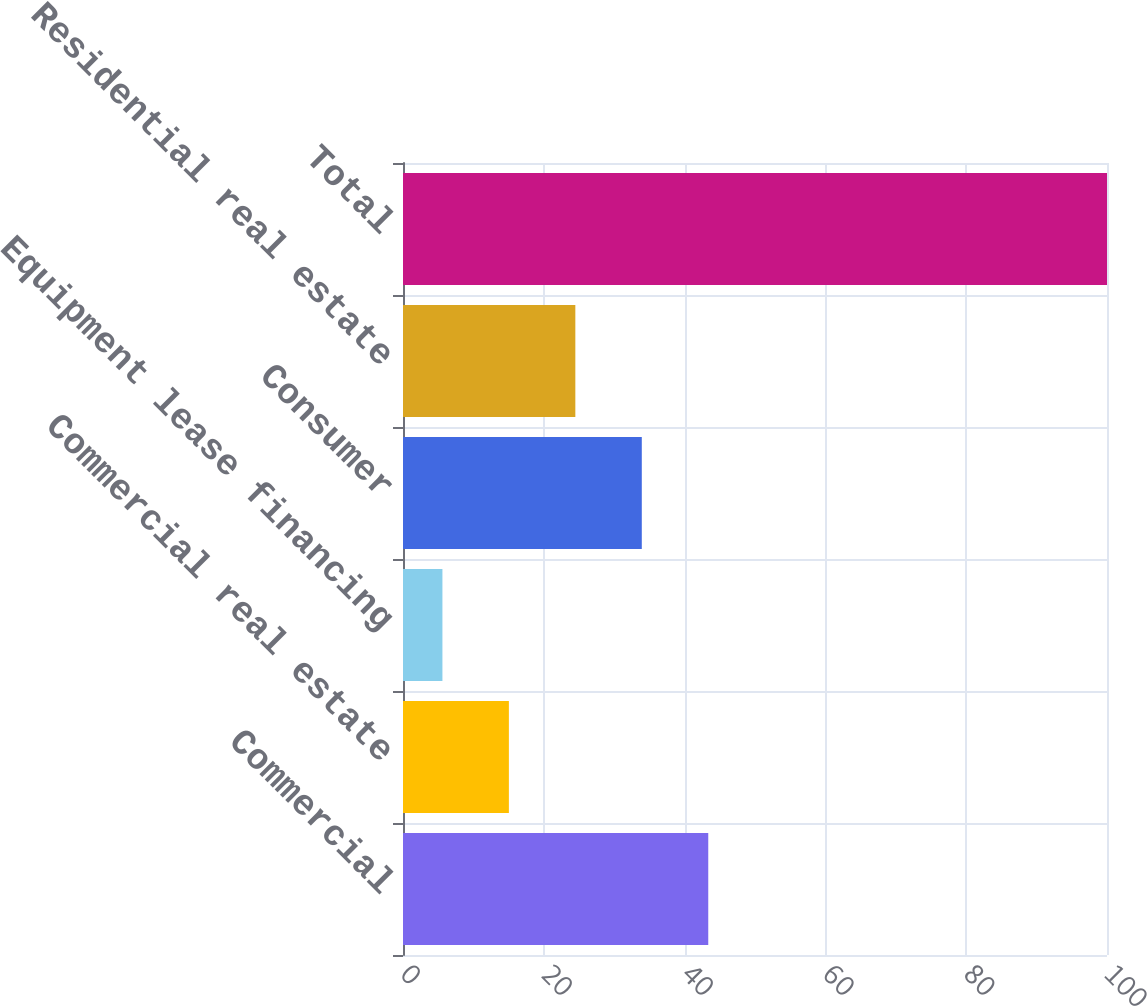Convert chart. <chart><loc_0><loc_0><loc_500><loc_500><bar_chart><fcel>Commercial<fcel>Commercial real estate<fcel>Equipment lease financing<fcel>Consumer<fcel>Residential real estate<fcel>Total<nl><fcel>43.36<fcel>15.04<fcel>5.6<fcel>33.92<fcel>24.48<fcel>100<nl></chart> 